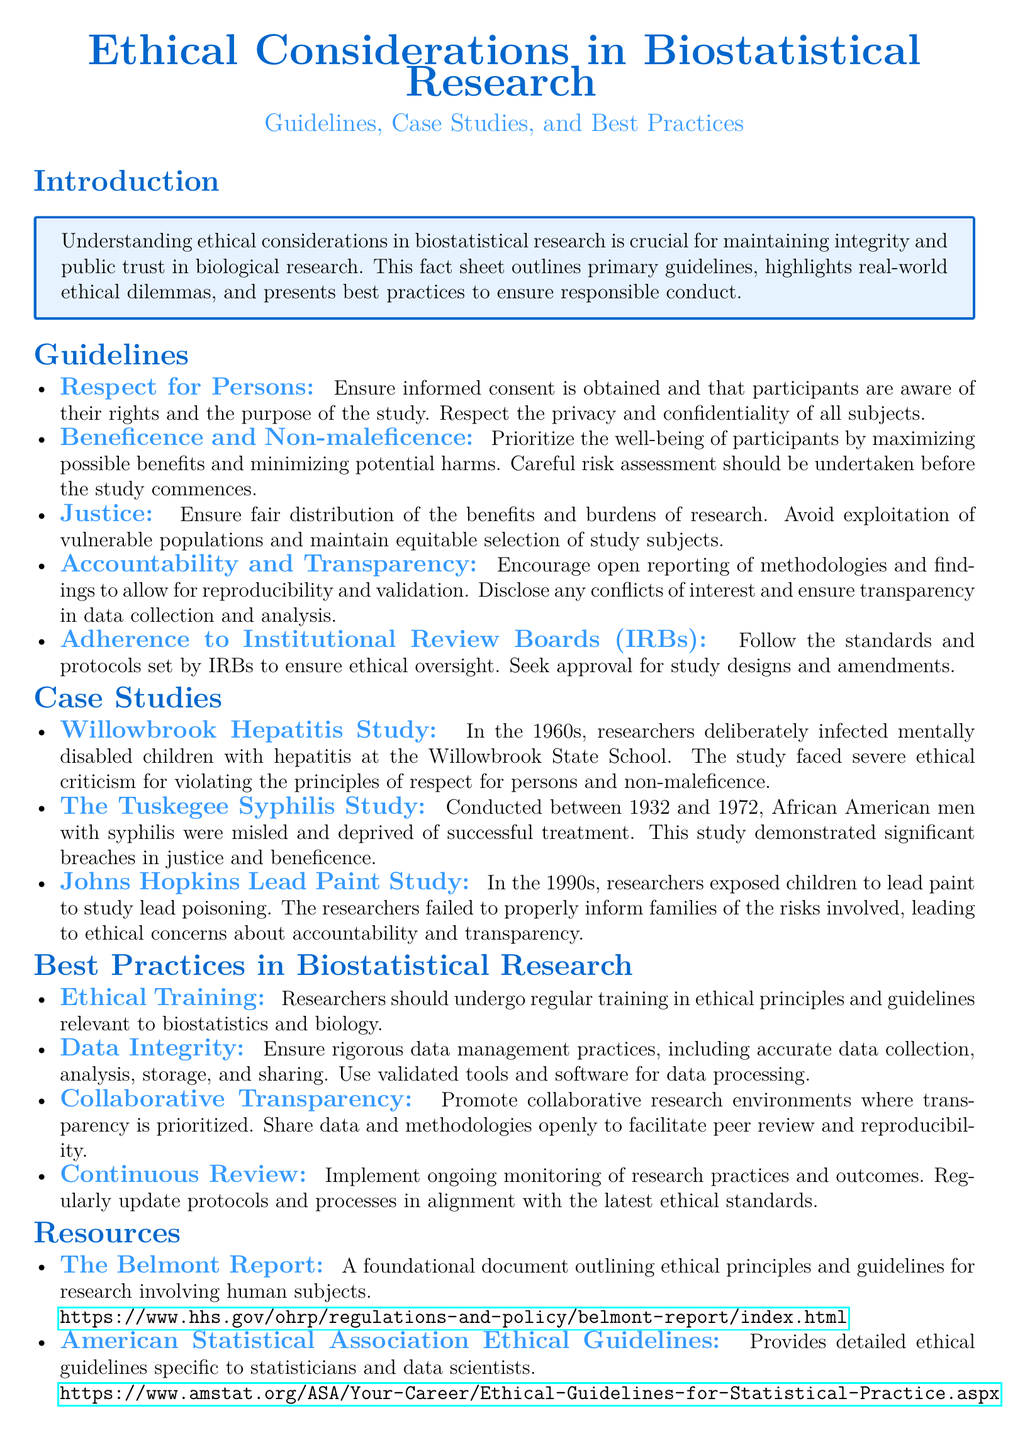What is the main focus of the fact sheet? The fact sheet primarily addresses ethical considerations in biostatistical research, including guidelines, case studies, and best practices.
Answer: ethical considerations in biostatistical research What principle emphasizes obtaining informed consent? This principle is outlined in the guidelines section, specifically under "Respect for Persons."
Answer: Respect for Persons Which case study involved misleading African American men? This refers to the historical study conducted between 1932 and 1972 involving syphilis.
Answer: The Tuskegee Syphilis Study How many ethical principles are outlined in the guidelines? The guidelines specify five principles for ethical conduct in biostatistical research.
Answer: five What is a recommended practice for researchers in biostatistical research? The best practices section advises researchers to participate in ethical training regularly.
Answer: Ethical Training What foundational document is mentioned regarding ethical principles? The document highlights The Belmont Report as a key resource for ethical guidelines in research.
Answer: The Belmont Report What is the focus of the Johns Hopkins Lead Paint Study case? This study raises ethical concerns regarding informed consent and family safety.
Answer: informed consent and family safety Which organization provides ethical guidelines specifically for statisticians? The American Statistical Association is mentioned as providing detailed ethical guidelines.
Answer: American Statistical Association What should researchers ensure for data integrity? Researchers should follow rigorous practices related to data management and accurate analysis.
Answer: rigorous data management practices 